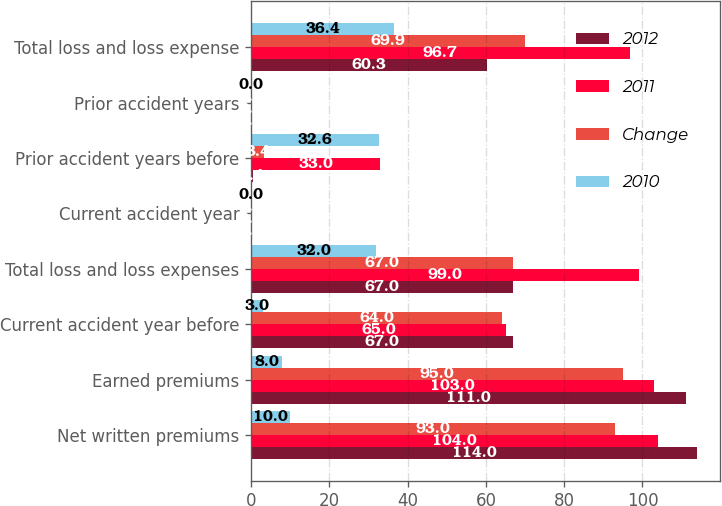Convert chart to OTSL. <chart><loc_0><loc_0><loc_500><loc_500><stacked_bar_chart><ecel><fcel>Net written premiums<fcel>Earned premiums<fcel>Current accident year before<fcel>Total loss and loss expenses<fcel>Current accident year<fcel>Prior accident years before<fcel>Prior accident years<fcel>Total loss and loss expense<nl><fcel>2012<fcel>114<fcel>111<fcel>67<fcel>67<fcel>0<fcel>0.4<fcel>0<fcel>60.3<nl><fcel>2011<fcel>104<fcel>103<fcel>65<fcel>99<fcel>0<fcel>33<fcel>0<fcel>96.7<nl><fcel>Change<fcel>93<fcel>95<fcel>64<fcel>67<fcel>0<fcel>3.4<fcel>0<fcel>69.9<nl><fcel>2010<fcel>10<fcel>8<fcel>3<fcel>32<fcel>0<fcel>32.6<fcel>0<fcel>36.4<nl></chart> 